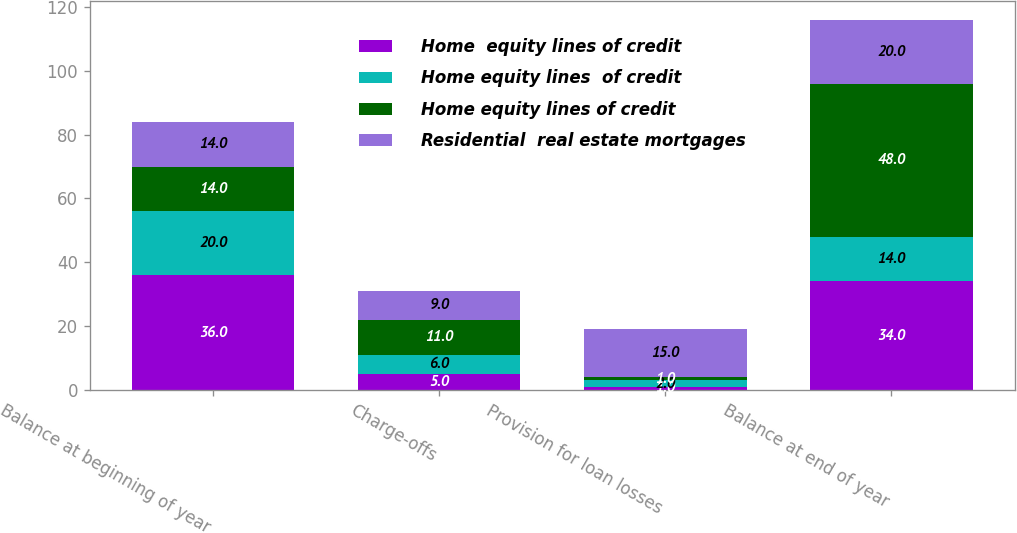<chart> <loc_0><loc_0><loc_500><loc_500><stacked_bar_chart><ecel><fcel>Balance at beginning of year<fcel>Charge-offs<fcel>Provision for loan losses<fcel>Balance at end of year<nl><fcel>Home  equity lines of credit<fcel>36<fcel>5<fcel>1<fcel>34<nl><fcel>Home equity lines  of credit<fcel>20<fcel>6<fcel>2<fcel>14<nl><fcel>Home equity lines of credit<fcel>14<fcel>11<fcel>1<fcel>48<nl><fcel>Residential  real estate mortgages<fcel>14<fcel>9<fcel>15<fcel>20<nl></chart> 